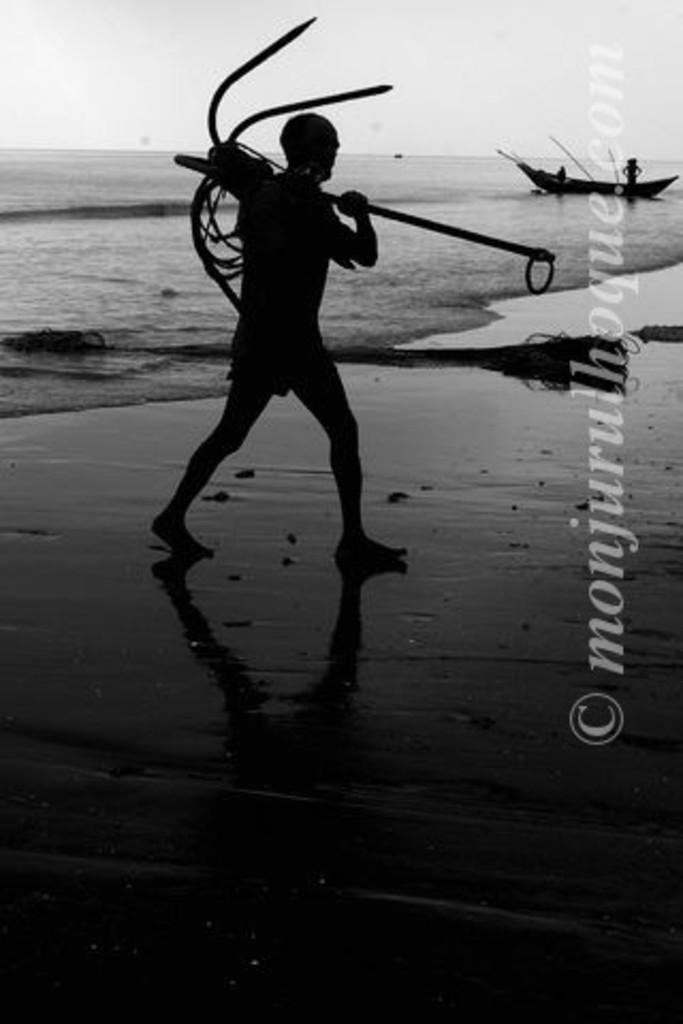<image>
Describe the image concisely. A man on a beach with the watermark mojurulhoque.com. 